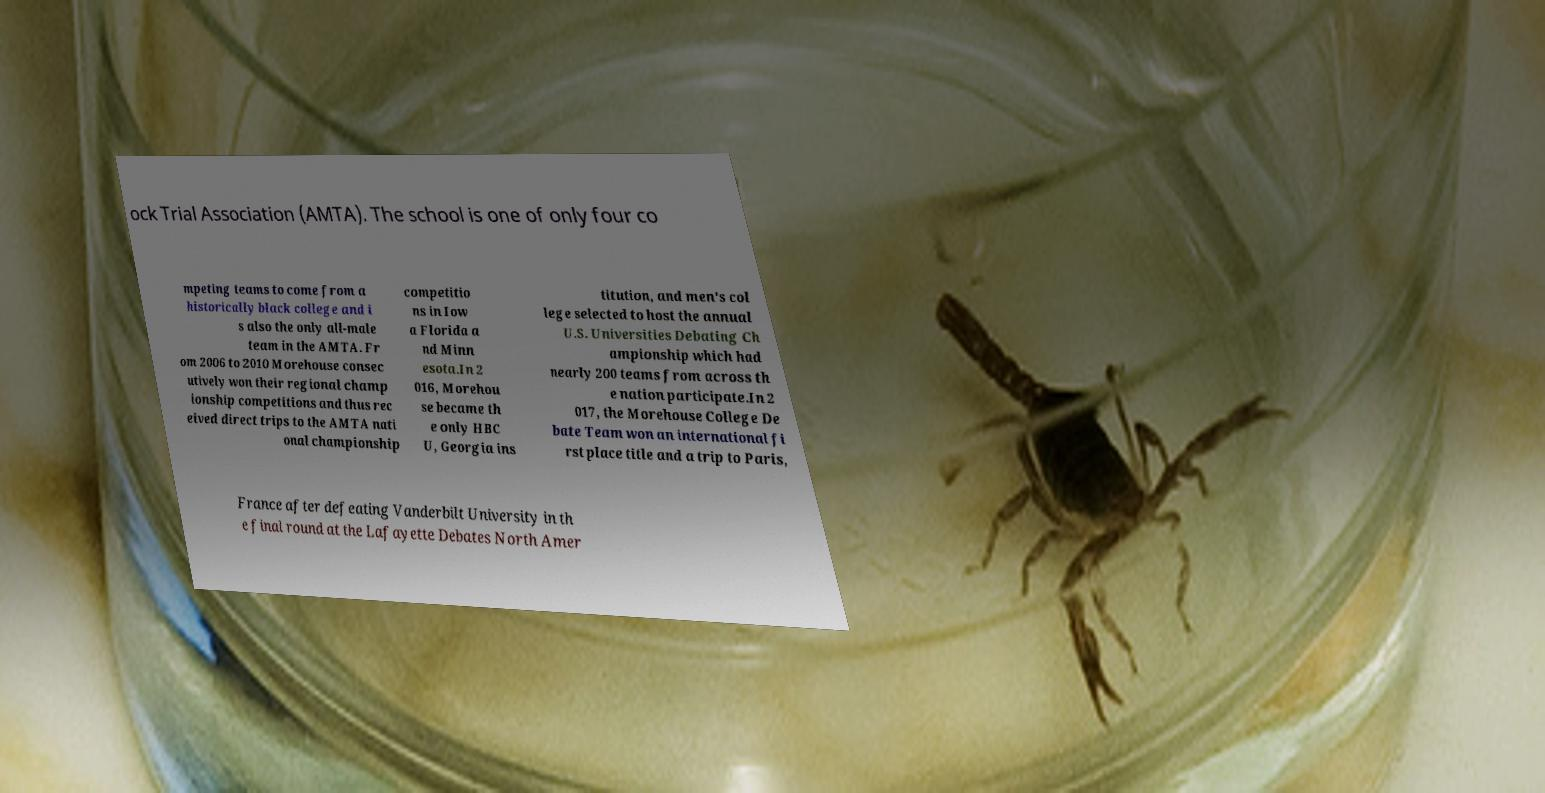Could you assist in decoding the text presented in this image and type it out clearly? ock Trial Association (AMTA). The school is one of only four co mpeting teams to come from a historically black college and i s also the only all-male team in the AMTA. Fr om 2006 to 2010 Morehouse consec utively won their regional champ ionship competitions and thus rec eived direct trips to the AMTA nati onal championship competitio ns in Iow a Florida a nd Minn esota.In 2 016, Morehou se became th e only HBC U, Georgia ins titution, and men's col lege selected to host the annual U.S. Universities Debating Ch ampionship which had nearly 200 teams from across th e nation participate.In 2 017, the Morehouse College De bate Team won an international fi rst place title and a trip to Paris, France after defeating Vanderbilt University in th e final round at the Lafayette Debates North Amer 